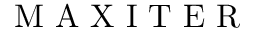<formula> <loc_0><loc_0><loc_500><loc_500>M A X I T E R</formula> 